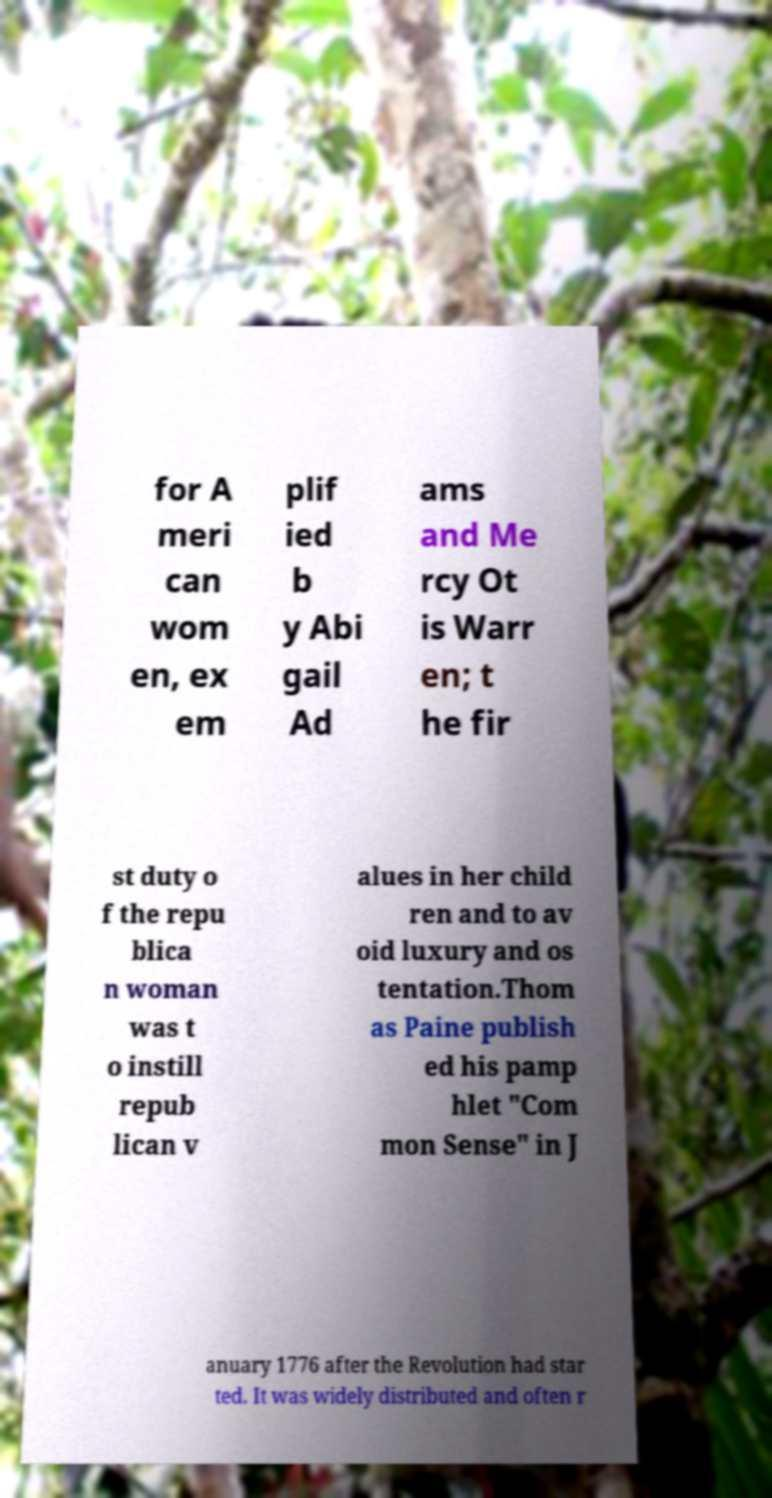Can you accurately transcribe the text from the provided image for me? for A meri can wom en, ex em plif ied b y Abi gail Ad ams and Me rcy Ot is Warr en; t he fir st duty o f the repu blica n woman was t o instill repub lican v alues in her child ren and to av oid luxury and os tentation.Thom as Paine publish ed his pamp hlet "Com mon Sense" in J anuary 1776 after the Revolution had star ted. It was widely distributed and often r 